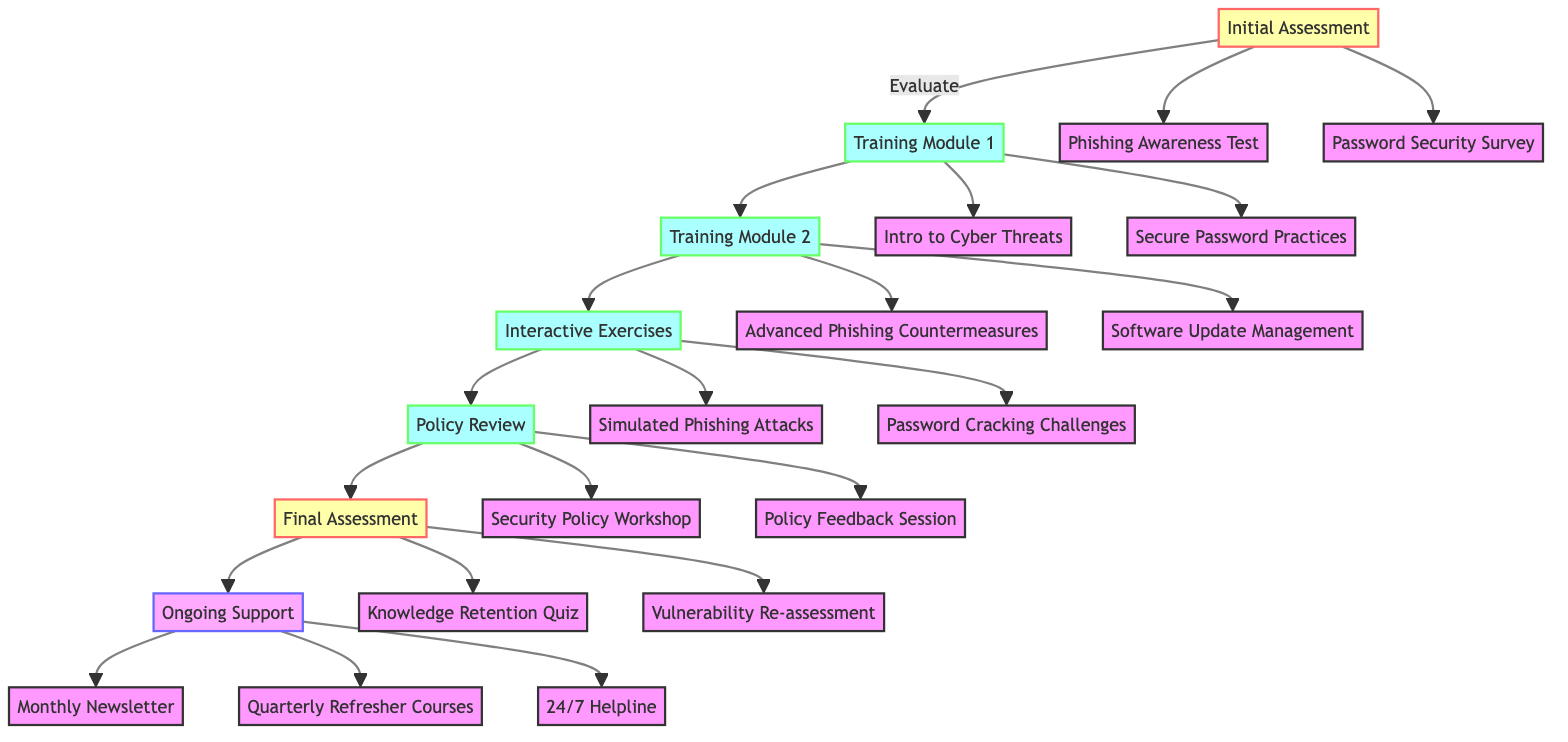What is the first step in the clinical pathway? The first step is labeled "Initial Assessment," which is the starting point of the training pathway.
Answer: Initial Assessment How many training modules are there? There are two training modules listed in the diagram; they are Training Module 1 and Training Module 2.
Answer: Two What type of assessment is at the end of the pathway? The final assessment is labeled "Final Assessment," which evaluates the effectiveness of the training.
Answer: Final Assessment What follows after the "Policy Review"? According to the flow, after the "Policy Review," the next step is the "Final Assessment."
Answer: Final Assessment What is the focus of the second training module? The focus of the second training module is "Advanced Threats and Vulnerability Management."
Answer: Advanced Threats and Vulnerability Management Which step includes hands-on activities? The step labeled "Interactive Exercises" involves practical, hands-on activities to reinforce training.
Answer: Interactive Exercises What are the components of the initial assessment? The initial assessment consists of a "Phishing Awareness Test" and a "Password Security Survey."
Answer: Phishing Awareness Test, Password Security Survey How many ongoing support options are mentioned? There are three ongoing support options listed: a monthly newsletter, quarterly refresher courses, and a 24/7 helpline.
Answer: Three What is the purpose of the "Policy Review" step? The purpose of the "Policy Review" step is to review and update company cybersecurity policies.
Answer: Review and update cybersecurity policies 